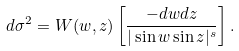<formula> <loc_0><loc_0><loc_500><loc_500>d \sigma ^ { 2 } = W ( w , z ) \left [ \frac { - d w d z } { | \sin w \sin z | ^ { s } } \right ] .</formula> 